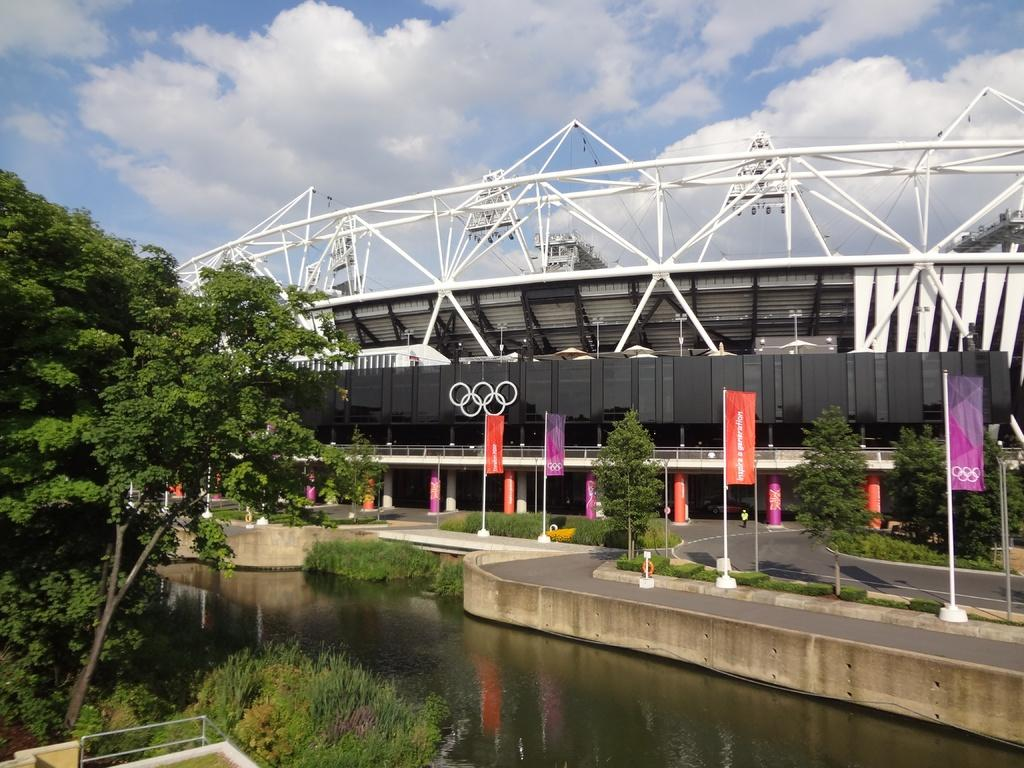What type of trees are in the image? There are trees in the image, but the specific type of trees cannot be determined from the provided facts. What can be seen in the water in the image? The image only states that there is water visible, but it does not describe what is in the water. What is the purpose of the road beside the water? The purpose of the road cannot be determined from the provided facts. What do the posters in the image advertise or display? The content of the posters cannot be determined from the provided facts. What type of plants are in the image? The specific type of plants cannot be determined from the provided facts. What is the function of the building in the image? The function of the building cannot be determined from the provided facts. What is the person standing on the ground doing? The actions of the person cannot be determined from the provided facts. What is the weather like in the image? The weather cannot be determined from the provided facts, but the sky is visible in the background. What type of poison is being served for lunch in the image? There is no mention of lunch or poison in the image; it features trees, water, a road, posters, plants, a building, a person, and the sky. 